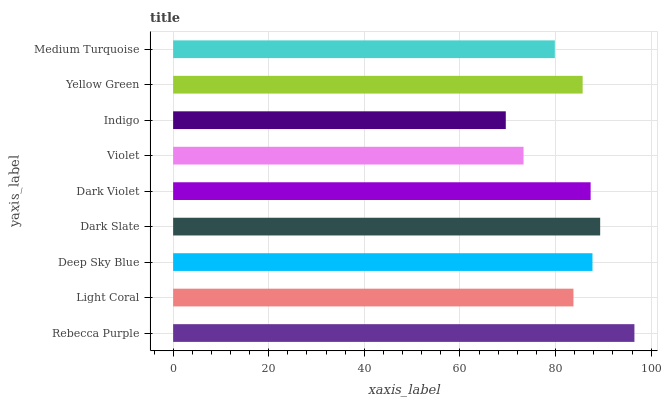Is Indigo the minimum?
Answer yes or no. Yes. Is Rebecca Purple the maximum?
Answer yes or no. Yes. Is Light Coral the minimum?
Answer yes or no. No. Is Light Coral the maximum?
Answer yes or no. No. Is Rebecca Purple greater than Light Coral?
Answer yes or no. Yes. Is Light Coral less than Rebecca Purple?
Answer yes or no. Yes. Is Light Coral greater than Rebecca Purple?
Answer yes or no. No. Is Rebecca Purple less than Light Coral?
Answer yes or no. No. Is Yellow Green the high median?
Answer yes or no. Yes. Is Yellow Green the low median?
Answer yes or no. Yes. Is Rebecca Purple the high median?
Answer yes or no. No. Is Medium Turquoise the low median?
Answer yes or no. No. 